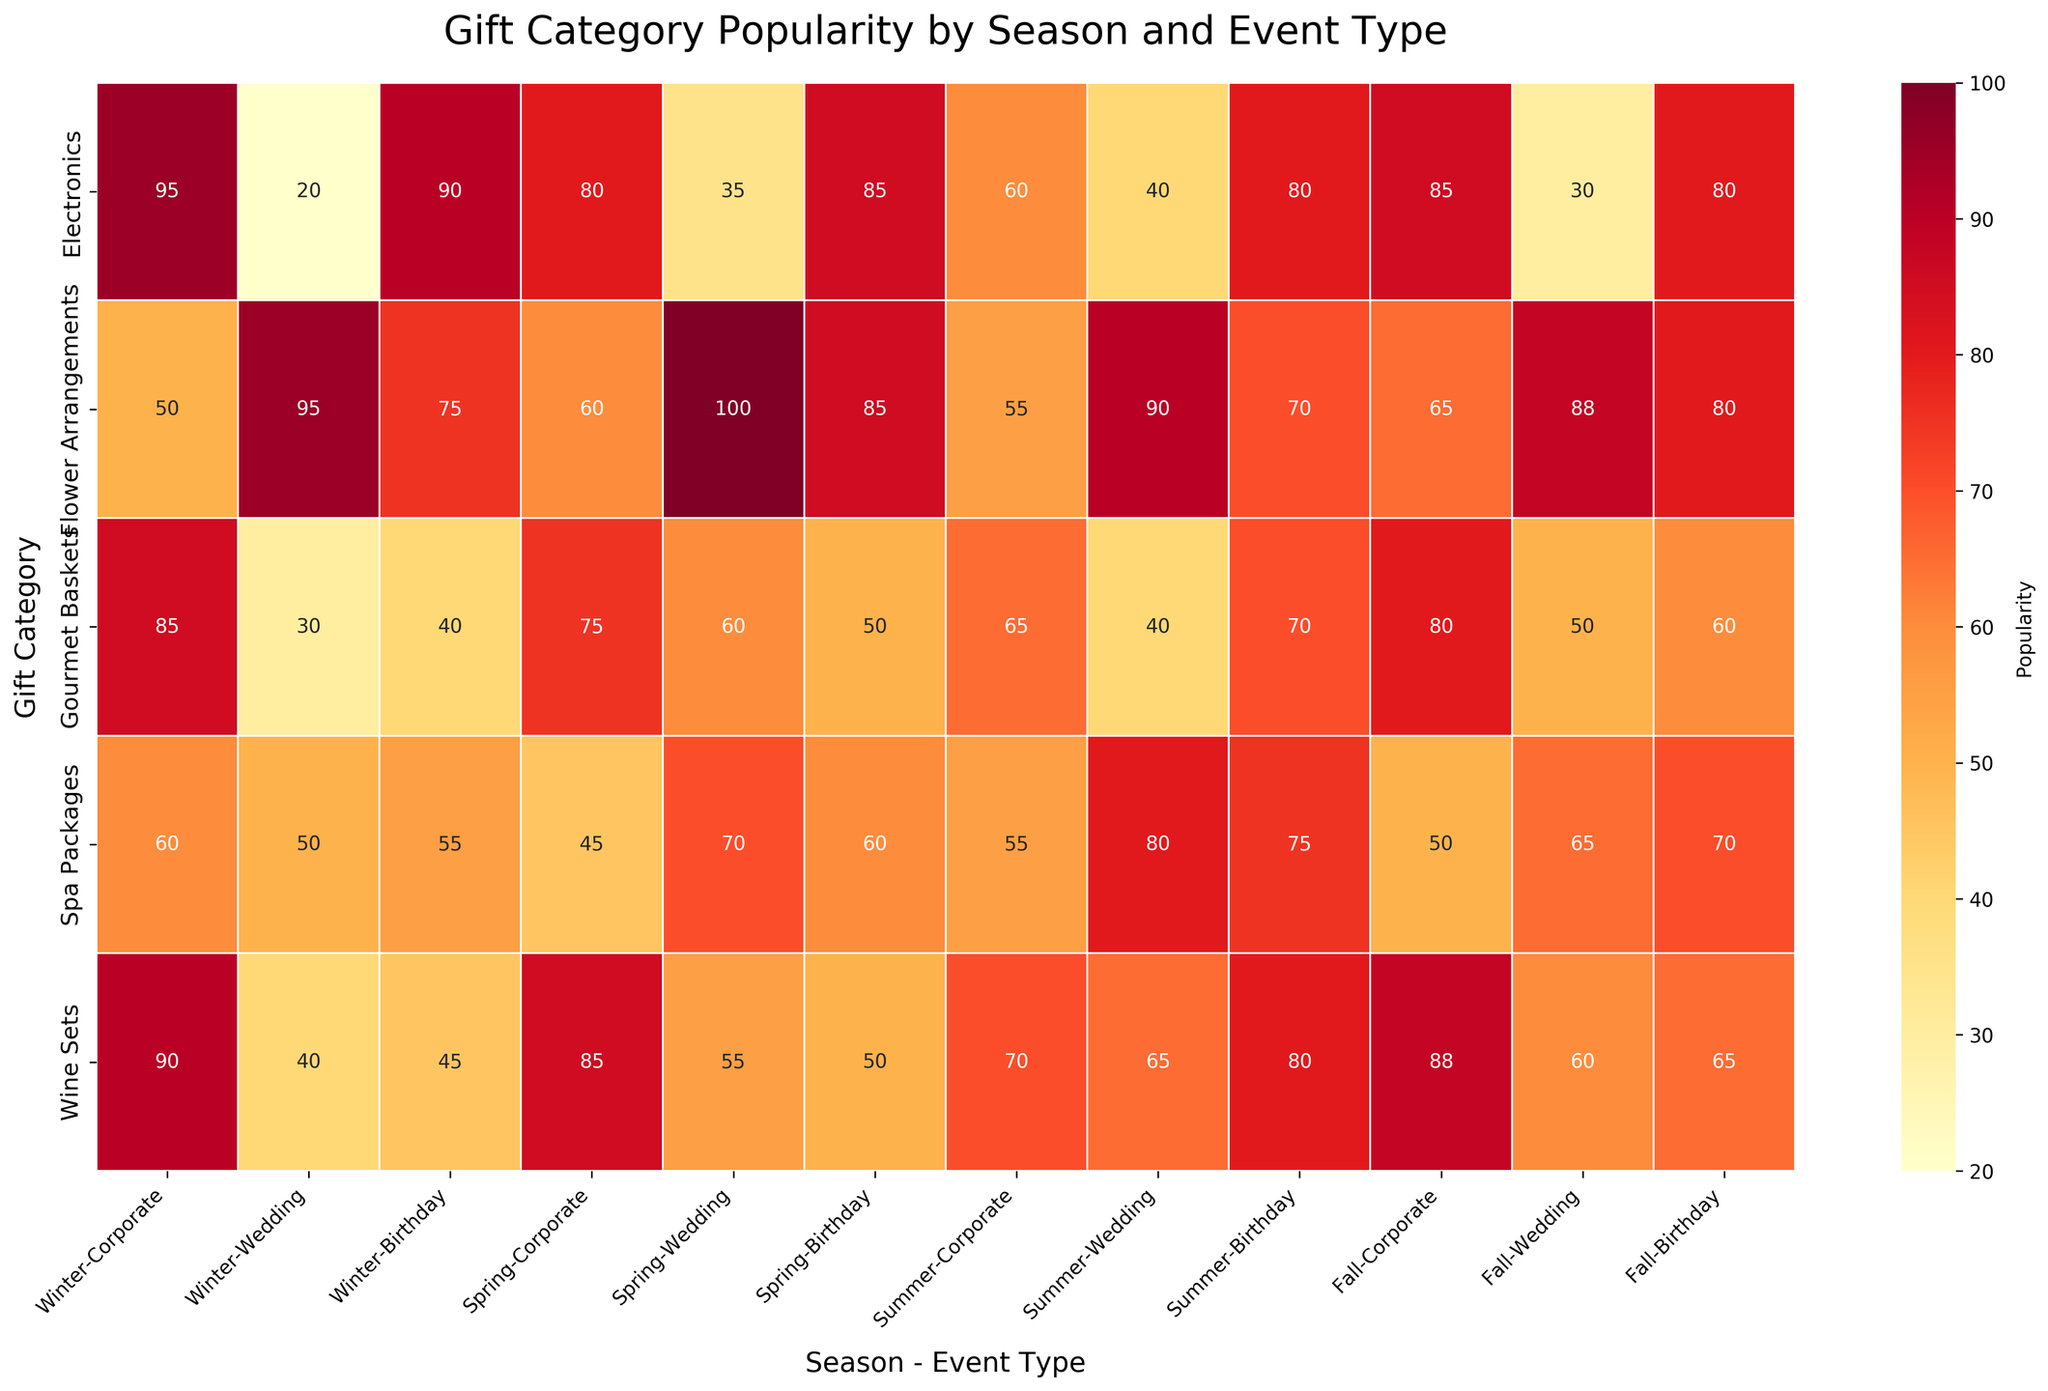What is the title of the figure? The title of the figure is written at the top and it provides a summary of the data represented.
Answer: Gift Category Popularity by Season and Event Type Which gift category is the most popular for corporate events in winter? Look at the intersection of the "Winter" column and "Corporate" event type row for each gift category; the highest value indicates the most popular gift category.
Answer: Electronics Which season has the highest popularity for flower arrangements in weddings? Examine the "Flower Arrangements" row and compare the popularity values across different seasons specifically for "Wedding" event type.
Answer: Spring What is the average popularity of wine sets for birthday events across all seasons? Sum the popularity values of "Wine Sets" for "Birthday" events in Winter, Spring, Summer, and Fall and then divide by the number of seasons. Popularities: 45 (Winter), 50 (Spring), 80 (Summer), 65 (Fall); (45 + 50 + 80 + 65) / 4 = 240 / 4
Answer: 60 Which event type has the least popularity for spa packages in fall? Check the popularity values for spa packages in fall and identify the event type with the lowest value.
Answer: Corporate Compare the popularity of gourmet baskets and flower arrangements for birthday events in summer. Which is higher? Look at the popularity values of "Birthday" in "Summer" for both "Gourmet Baskets" and "Flower Arrangements." Compare the two values.
Answer: Flower Arrangements Find the difference in popularity for electronics between corporate and wedding events in spring. Locate the popularity values for "Electronics" under "Spring" for both "Corporate" and "Wedding" events and subtract the smaller value from the larger value. 80 (Corporate) - 35 (Wedding) = 45
Answer: 45 Which gift category has the highest average popularity for all event types in winter? Average the popularity values for each gift category in "Winter" across all event types and identify the highest. Average values: Gourmet Baskets (85 + 30 + 40)/3 = 155/3 ≈ 51.67, Spa Packages (60 + 50 + 50)/3 ≈ 53.33, Wine Sets (90 + 40 + 45)/3 = 175/3 ≈ 58.33, Electronics (95 + 20 + 90)/3 = 205/3 ≈ 68.33, Flower Arrangements (50 + 95 + 75)/3 = 220/3 ≈ 73.33
Answer: Electronics Which season has the overall highest popularity value for any gift category and event type? Scan the heatmap to identify the highest value across all gift categories, event types, and seasons.
Answer: Winter 